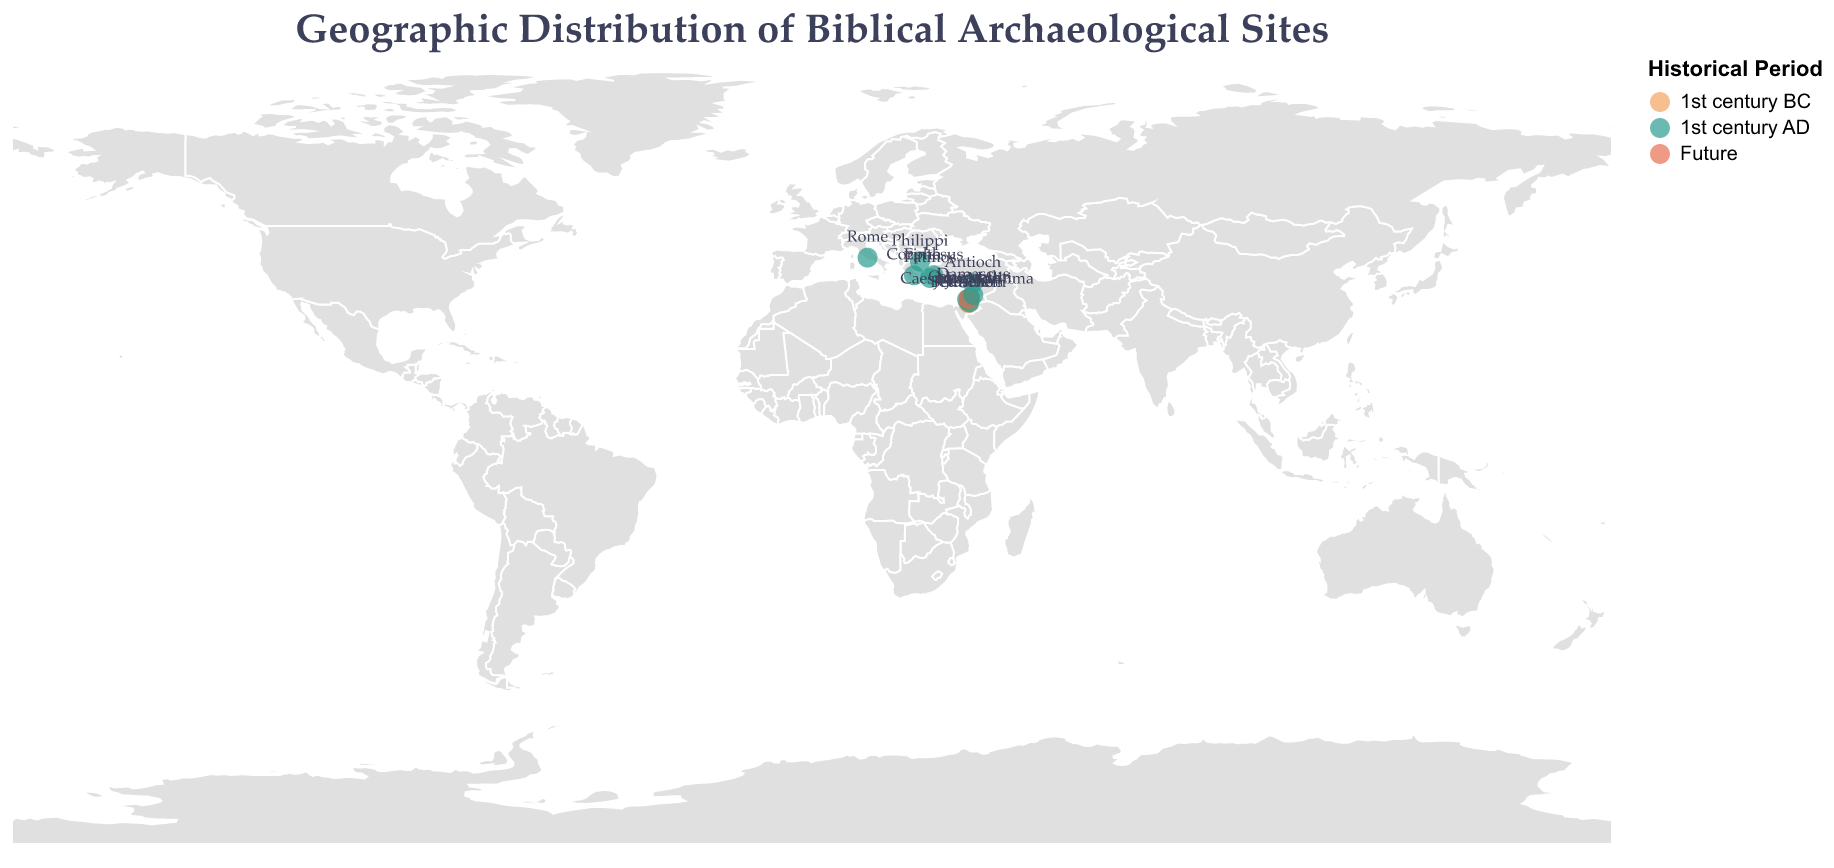What's the title of the figure? The title is displayed clearly at the top of the figure.
Answer: Geographic Distribution of Biblical Archaeological Sites How many sites are marked on the map? Each marked site is represented by a circle on the map. Count the number of circles to determine the number of sites.
Answer: 14 Which historical period has the majority of sites? Look at the color coding of the circles to determine the main period for the sites. Most circles are represented by the color assigned to the 1st century AD.
Answer: 1st century AD Which site is located at the farthest North? Look at the latitude values for each site; the highest latitude value indicates the site farthest north.
Answer: Philippi Which three sites are in close proximity within the region of modern-day Israel? Observe the clusters of circles on the map to identify sites that are geographically close to each other. In modern-day Israel, Jerusalem, Bethlehem, and Jericho are clustered together.
Answer: Jerusalem, Bethlehem, Jericho What is the significance of the site located in the future period? By looking at the tooltip information for the site with the color representing the future, you can find its significance. Megiddo is marked for the future and its significance is the prophesied site of Armageddon.
Answer: Prophesied site of Armageddon Which site is associated with the first use of the term "Christian"? Hover over the circles or observe the data points to find the site with its significance listed as the first use of the term "Christian". This information is associated with Antioch.
Answer: Antioch Compare the locations of Ephesus and Corinth based on their longitude; which is farther east? Check the longitude values for both sites; the greater the longitude, the farther east the site is located. Ephesus has a longitude of 27.3423, and Corinth has a longitude of 22.9324. Ephesus is farther east.
Answer: Ephesus What is common between the sites of Paul's missionary work and Paul's conversion? Review the significance attached to each site to identify similarities. Ephesus (Paul's missionary work) and Damascus (Paul's conversion) are both related to Paul's activities in the 1st century AD.
Answer: Both related to Paul's activities in the 1st century AD 